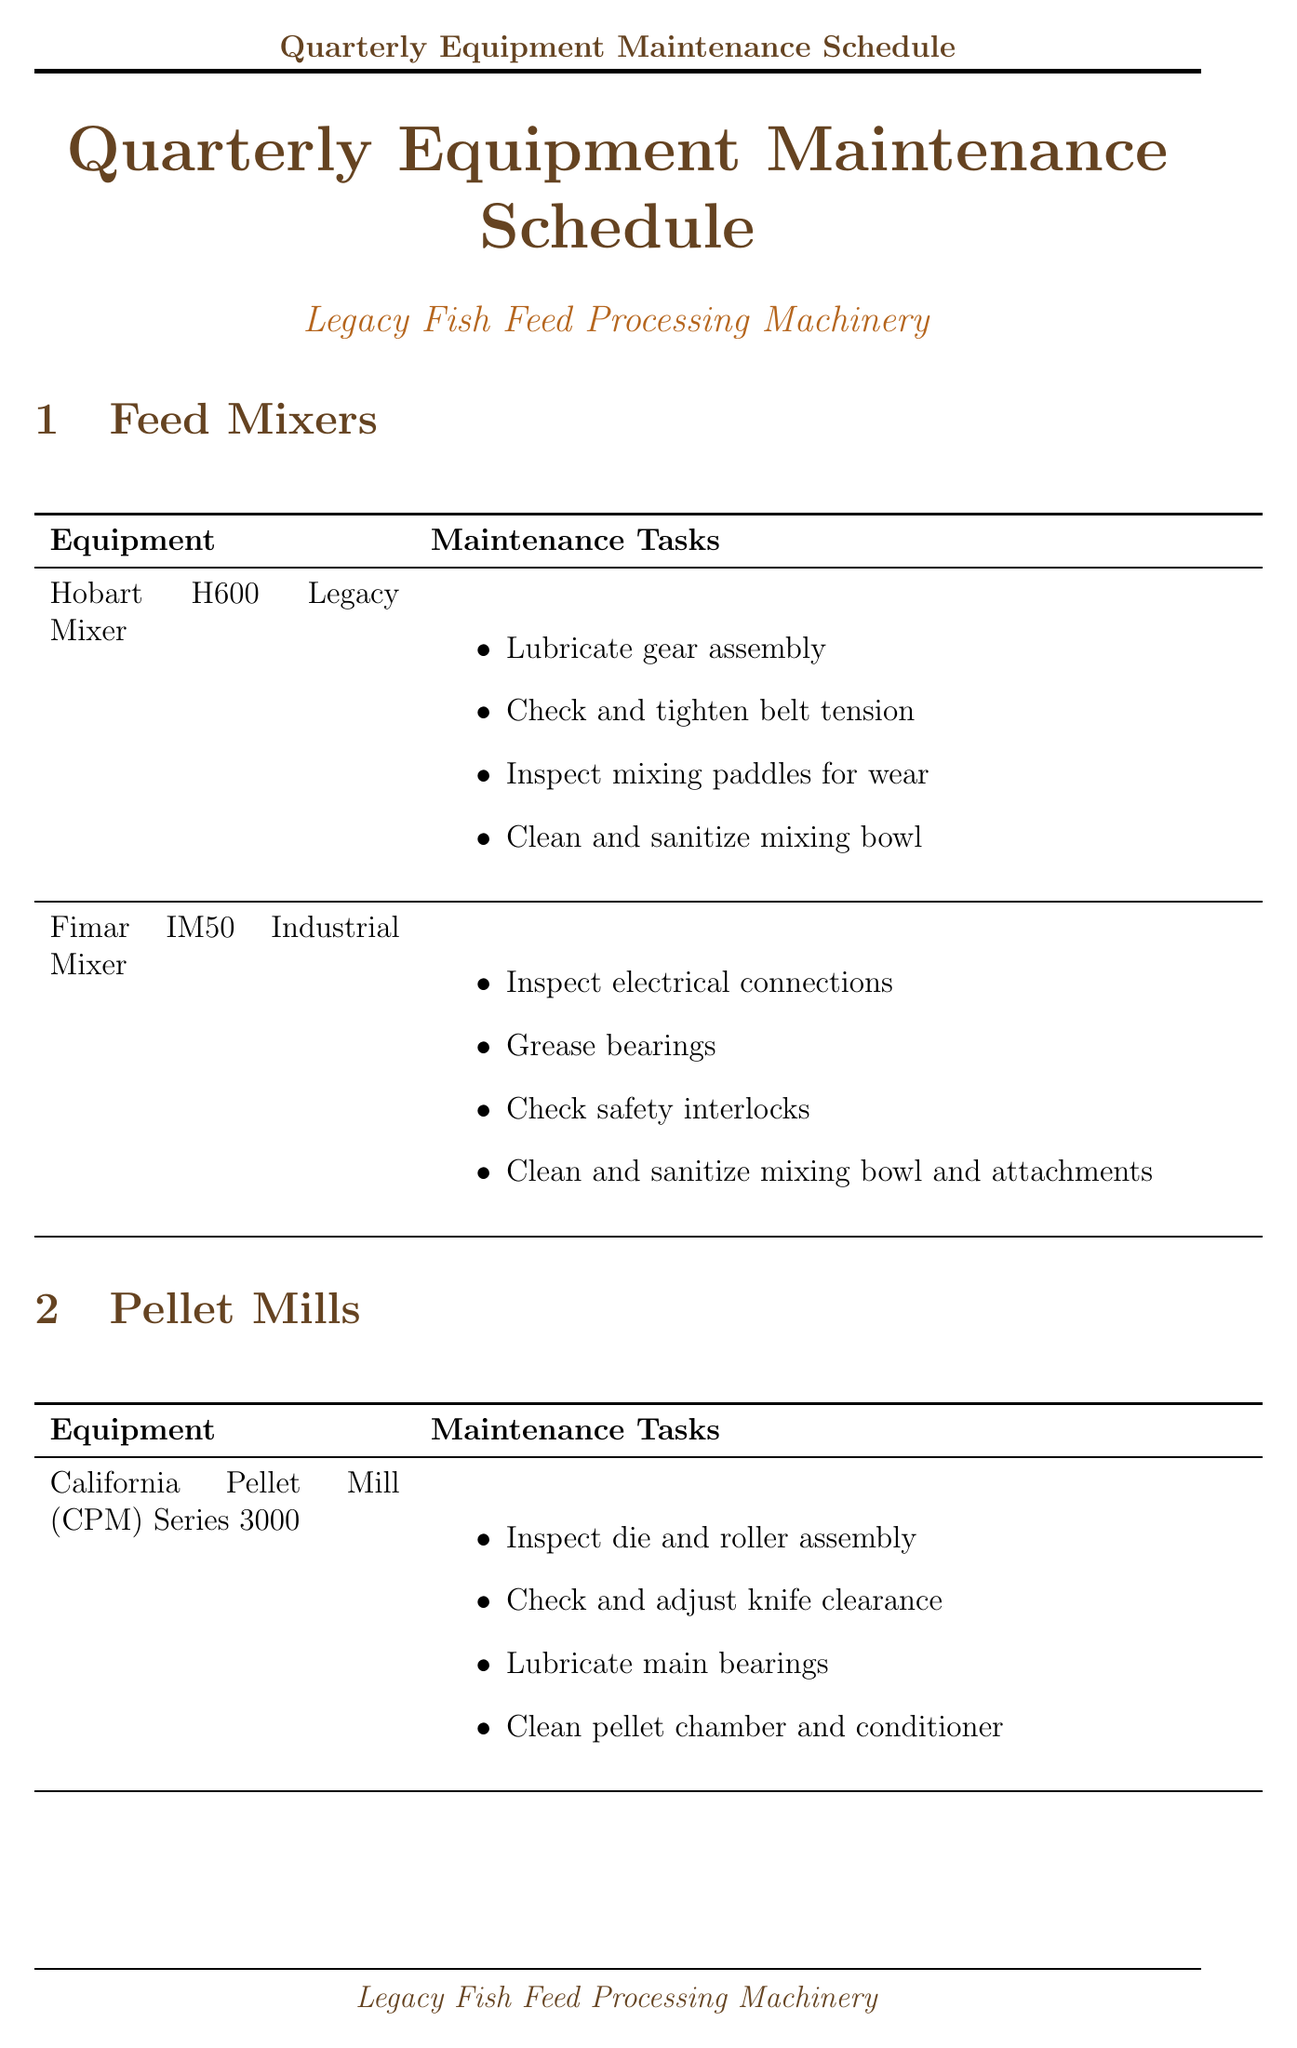what is the maintenance frequency for Hobart H600 Legacy Mixer? The maintenance frequency for Hobart H600 Legacy Mixer is specified as quarterly in the document.
Answer: Quarterly how many maintenance tasks are listed for Fimar IM50 Industrial Mixer? The document lists four maintenance tasks for Fimar IM50 Industrial Mixer.
Answer: Four what equipment falls under the category of dryers? The document lists two pieces of equipment in the dryers category: Bühler OmniFan Dryer and Wenger Series IV Dryer.
Answer: Bühler OmniFan Dryer and Wenger Series IV Dryer which category does Jacobson Full Circle Hammermill belong to? The document categorizes the Jacobson Full Circle Hammermill under the grinders section.
Answer: Grinders what is one additional consideration stated in the document? The document includes several additional considerations, one of which is to prioritize thorough cleaning and sanitation to maintain feed quality.
Answer: Prioritize thorough cleaning and sanitation to maintain feed quality how many pieces of equipment are listed in the pellet mills section? The pellet mills section lists two pieces of equipment: California Pellet Mill (CPM) Series 3000 and Buskirk Engineering BE300 Pellet Mill.
Answer: Two what precaution should always be followed before performing maintenance? The document states that one should always follow lockout/tagout procedures before performing maintenance.
Answer: Lockout/tagout procedures which piece of equipment requires lubrication of bearings in its maintenance tasks? The maintenance tasks for Flexicon Flexible Screw Conveyor include lubrication of bearings as one of the tasks.
Answer: Flexicon Flexible Screw Conveyor how many total categories are mentioned in the document? The document outlines five total categories of equipment: Feed Mixers, Pellet Mills, Dryers, Grinders, and Conveying Systems.
Answer: Five 